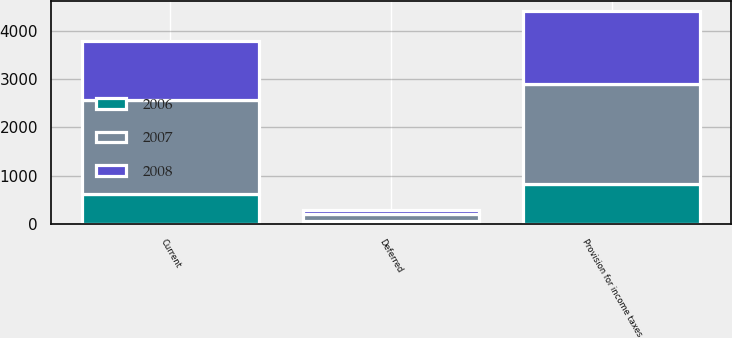<chart> <loc_0><loc_0><loc_500><loc_500><stacked_bar_chart><ecel><fcel>Current<fcel>Deferred<fcel>Provision for income taxes<nl><fcel>2007<fcel>1942<fcel>155<fcel>2061<nl><fcel>2008<fcel>1219<fcel>85<fcel>1512<nl><fcel>2006<fcel>619<fcel>56<fcel>829<nl></chart> 